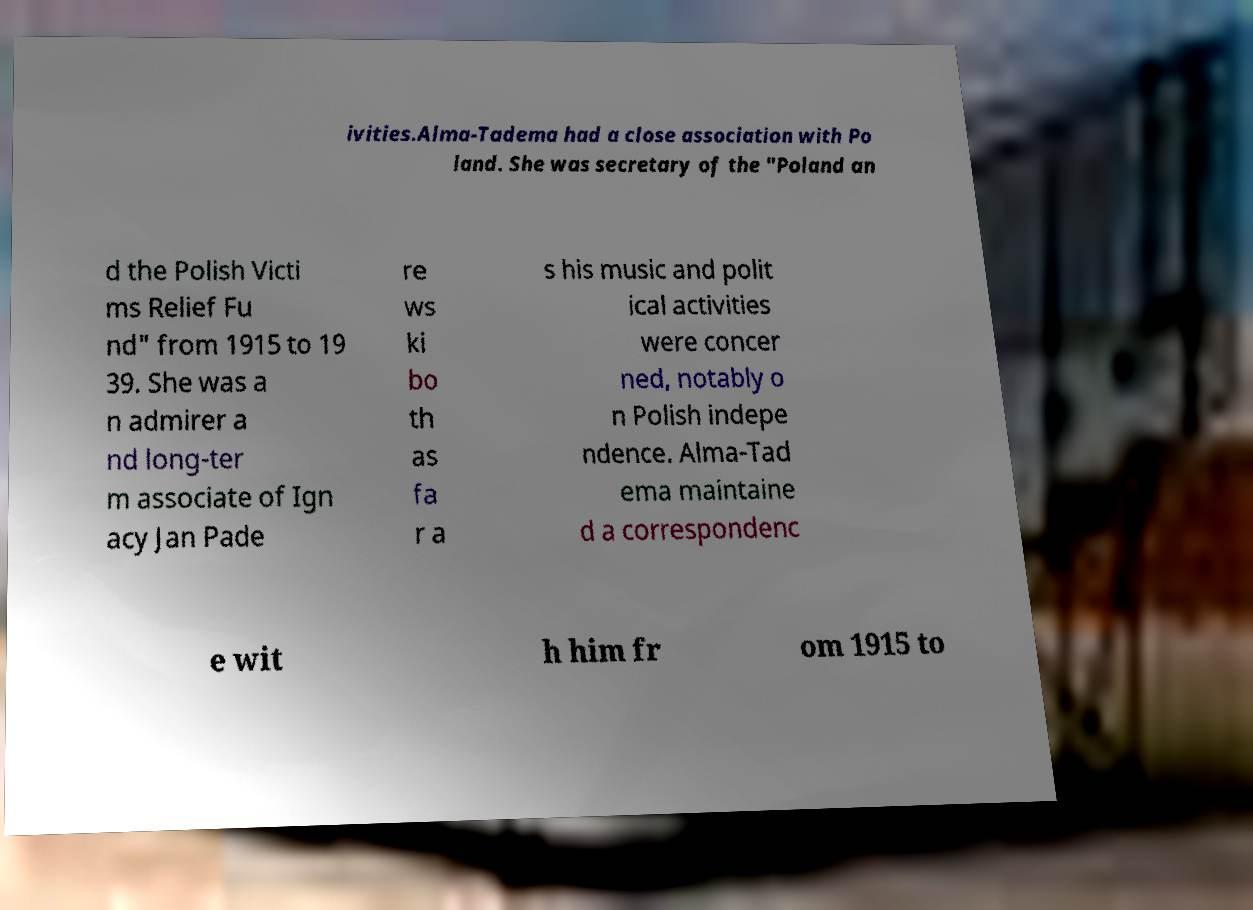Can you accurately transcribe the text from the provided image for me? ivities.Alma-Tadema had a close association with Po land. She was secretary of the "Poland an d the Polish Victi ms Relief Fu nd" from 1915 to 19 39. She was a n admirer a nd long-ter m associate of Ign acy Jan Pade re ws ki bo th as fa r a s his music and polit ical activities were concer ned, notably o n Polish indepe ndence. Alma-Tad ema maintaine d a correspondenc e wit h him fr om 1915 to 